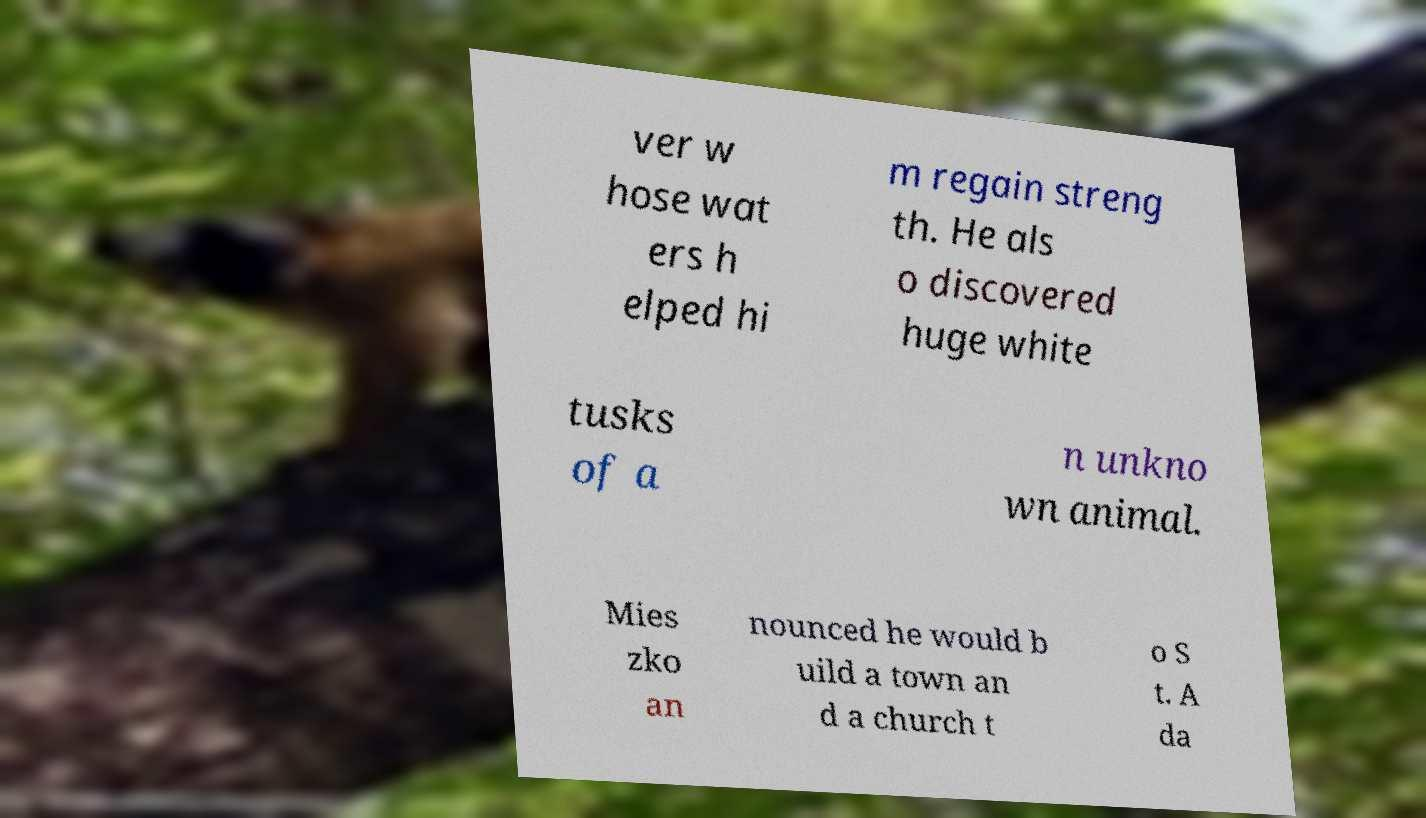I need the written content from this picture converted into text. Can you do that? ver w hose wat ers h elped hi m regain streng th. He als o discovered huge white tusks of a n unkno wn animal. Mies zko an nounced he would b uild a town an d a church t o S t. A da 